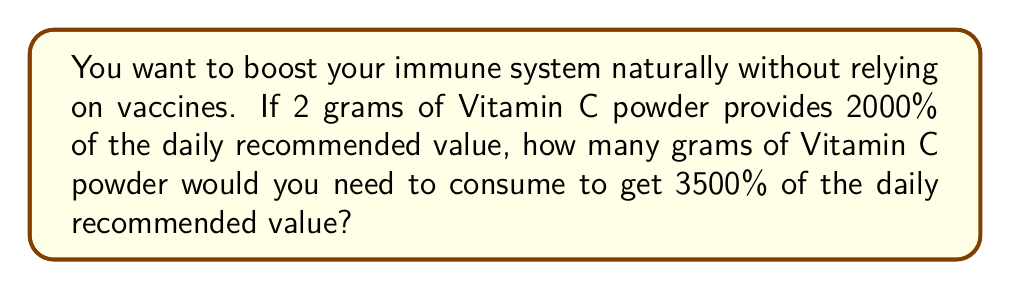Show me your answer to this math problem. Let's approach this step-by-step using proportions:

1) First, let's set up our proportion:
   
   $$\frac{2 \text{ grams}}{2000\%} = \frac{x \text{ grams}}{3500\%}$$

2) In this proportion, we're saying that the ratio of grams to percentage is constant.

3) To solve for $x$, we can cross-multiply:

   $$2 \cdot 3500 = 2000x$$

4) Simplify the left side:

   $$7000 = 2000x$$

5) Now, divide both sides by 2000:

   $$\frac{7000}{2000} = x$$

6) Simplify:

   $$3.5 = x$$

Therefore, you would need 3.5 grams of Vitamin C powder to get 3500% of the daily recommended value.
Answer: $3.5$ grams 